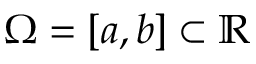<formula> <loc_0><loc_0><loc_500><loc_500>\Omega = [ a , b ] \subset \mathbb { R }</formula> 